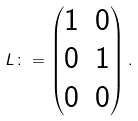<formula> <loc_0><loc_0><loc_500><loc_500>L \colon = \begin{pmatrix} 1 & 0 \\ 0 & 1 \\ 0 & 0 \end{pmatrix} .</formula> 